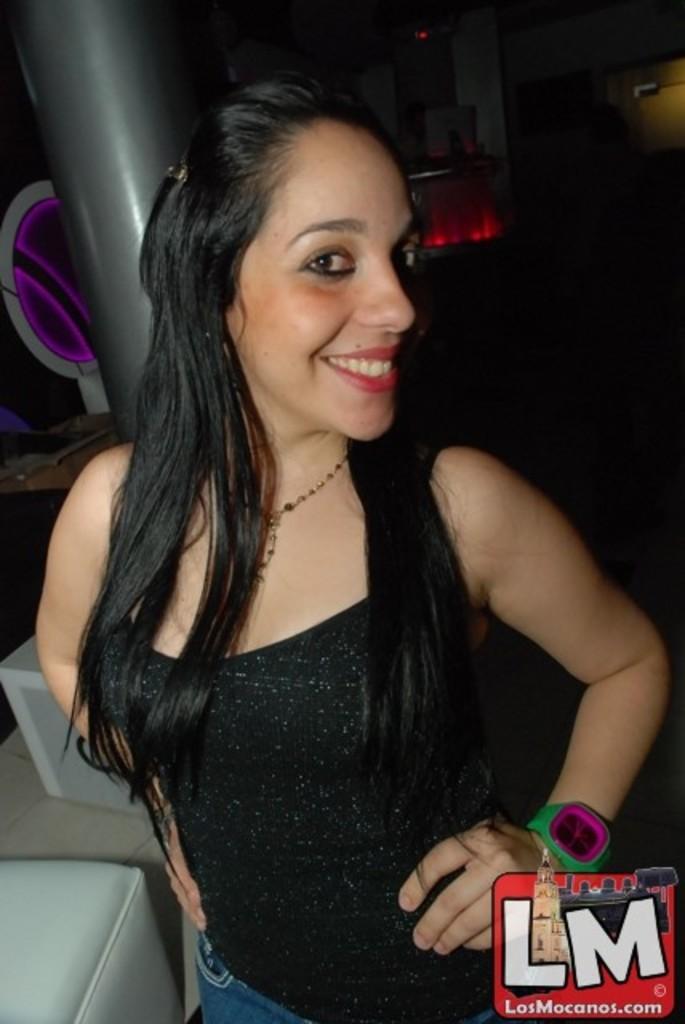In one or two sentences, can you explain what this image depicts? In this image I can see the person with black and blue color dress. To the left I can see the ash color couch, pole and the board. And there is a red and black background. 